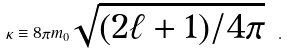<formula> <loc_0><loc_0><loc_500><loc_500>\kappa \equiv 8 \pi m _ { 0 } \sqrt { ( 2 \ell + 1 ) / 4 \pi } \ .</formula> 